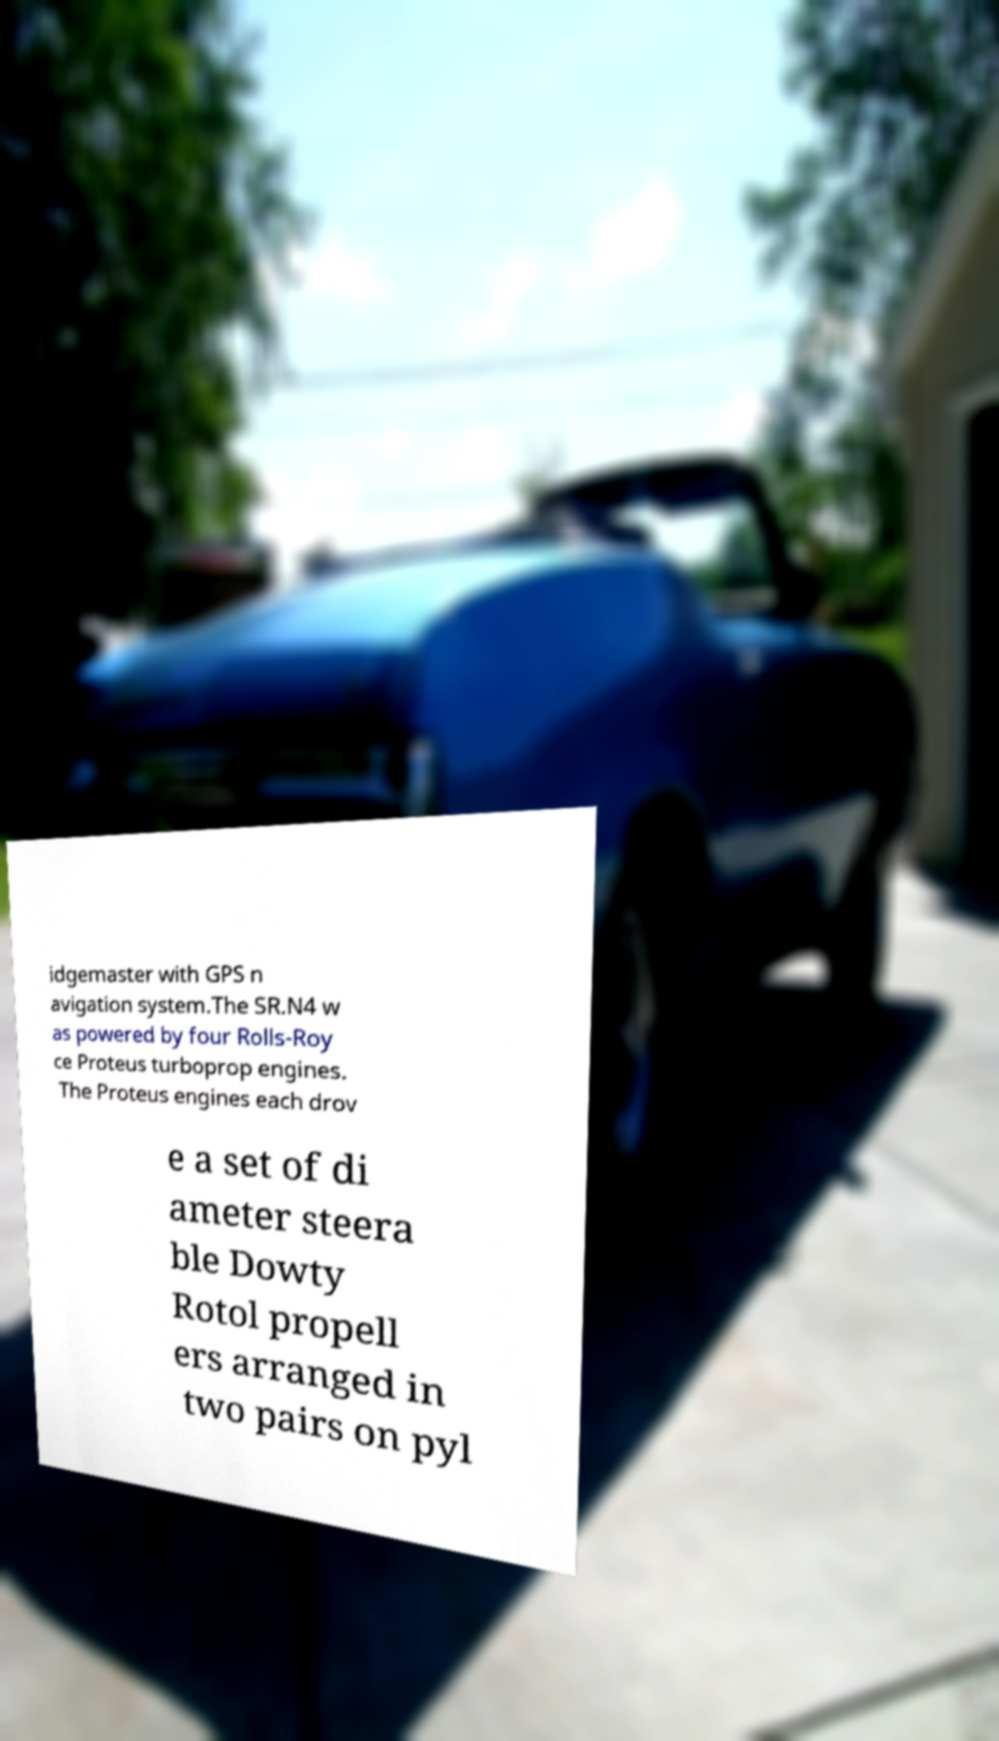I need the written content from this picture converted into text. Can you do that? idgemaster with GPS n avigation system.The SR.N4 w as powered by four Rolls-Roy ce Proteus turboprop engines. The Proteus engines each drov e a set of di ameter steera ble Dowty Rotol propell ers arranged in two pairs on pyl 